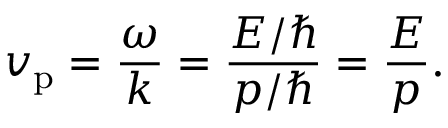<formula> <loc_0><loc_0><loc_500><loc_500>v _ { p } = { \frac { \omega } { k } } = { \frac { E / } { p / } } = { \frac { E } { p } } .</formula> 